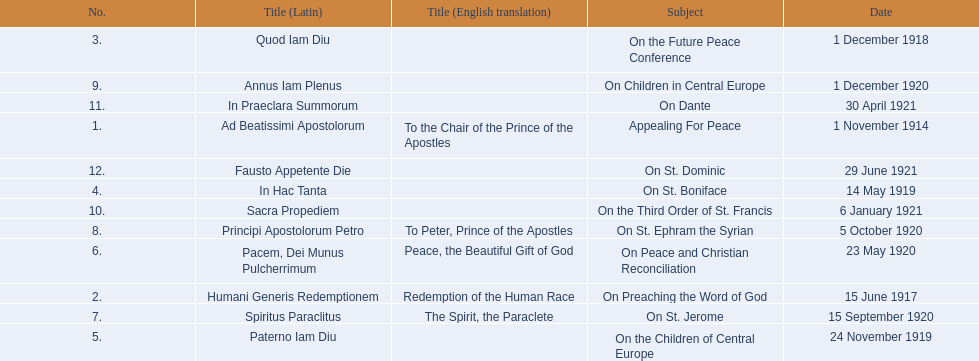How many titles did not list an english translation? 7. 